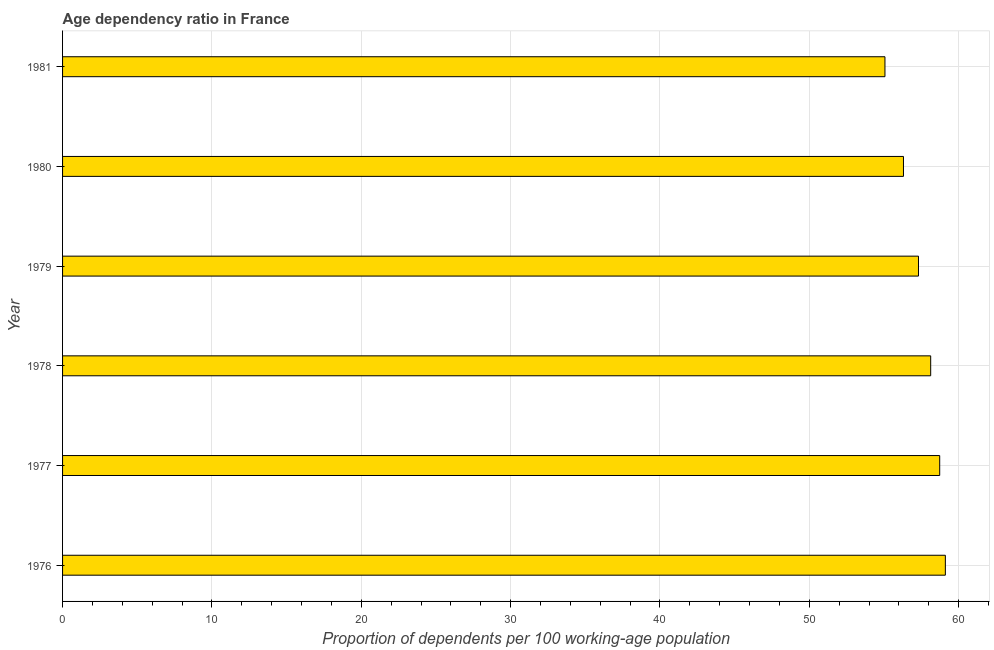Does the graph contain any zero values?
Your answer should be compact. No. Does the graph contain grids?
Make the answer very short. Yes. What is the title of the graph?
Provide a short and direct response. Age dependency ratio in France. What is the label or title of the X-axis?
Keep it short and to the point. Proportion of dependents per 100 working-age population. What is the label or title of the Y-axis?
Your answer should be very brief. Year. What is the age dependency ratio in 1978?
Your answer should be very brief. 58.13. Across all years, what is the maximum age dependency ratio?
Provide a short and direct response. 59.11. Across all years, what is the minimum age dependency ratio?
Your answer should be compact. 55.06. In which year was the age dependency ratio maximum?
Keep it short and to the point. 1976. What is the sum of the age dependency ratio?
Your response must be concise. 344.63. What is the difference between the age dependency ratio in 1976 and 1981?
Make the answer very short. 4.04. What is the average age dependency ratio per year?
Your answer should be compact. 57.44. What is the median age dependency ratio?
Make the answer very short. 57.72. In how many years, is the age dependency ratio greater than 20 ?
Your answer should be compact. 6. Do a majority of the years between 1978 and 1981 (inclusive) have age dependency ratio greater than 14 ?
Keep it short and to the point. Yes. What is the ratio of the age dependency ratio in 1980 to that in 1981?
Your response must be concise. 1.02. Is the age dependency ratio in 1978 less than that in 1980?
Give a very brief answer. No. What is the difference between the highest and the second highest age dependency ratio?
Provide a short and direct response. 0.38. Is the sum of the age dependency ratio in 1978 and 1979 greater than the maximum age dependency ratio across all years?
Offer a very short reply. Yes. What is the difference between the highest and the lowest age dependency ratio?
Provide a short and direct response. 4.04. In how many years, is the age dependency ratio greater than the average age dependency ratio taken over all years?
Your answer should be compact. 3. How many years are there in the graph?
Your response must be concise. 6. What is the difference between two consecutive major ticks on the X-axis?
Make the answer very short. 10. What is the Proportion of dependents per 100 working-age population in 1976?
Provide a succinct answer. 59.11. What is the Proportion of dependents per 100 working-age population of 1977?
Make the answer very short. 58.73. What is the Proportion of dependents per 100 working-age population of 1978?
Your answer should be compact. 58.13. What is the Proportion of dependents per 100 working-age population of 1979?
Your response must be concise. 57.31. What is the Proportion of dependents per 100 working-age population in 1980?
Offer a very short reply. 56.3. What is the Proportion of dependents per 100 working-age population of 1981?
Ensure brevity in your answer.  55.06. What is the difference between the Proportion of dependents per 100 working-age population in 1976 and 1977?
Make the answer very short. 0.38. What is the difference between the Proportion of dependents per 100 working-age population in 1976 and 1978?
Keep it short and to the point. 0.98. What is the difference between the Proportion of dependents per 100 working-age population in 1976 and 1979?
Give a very brief answer. 1.8. What is the difference between the Proportion of dependents per 100 working-age population in 1976 and 1980?
Your answer should be compact. 2.8. What is the difference between the Proportion of dependents per 100 working-age population in 1976 and 1981?
Keep it short and to the point. 4.04. What is the difference between the Proportion of dependents per 100 working-age population in 1977 and 1978?
Your answer should be compact. 0.6. What is the difference between the Proportion of dependents per 100 working-age population in 1977 and 1979?
Give a very brief answer. 1.42. What is the difference between the Proportion of dependents per 100 working-age population in 1977 and 1980?
Make the answer very short. 2.43. What is the difference between the Proportion of dependents per 100 working-age population in 1977 and 1981?
Offer a very short reply. 3.67. What is the difference between the Proportion of dependents per 100 working-age population in 1978 and 1979?
Offer a terse response. 0.82. What is the difference between the Proportion of dependents per 100 working-age population in 1978 and 1980?
Keep it short and to the point. 1.82. What is the difference between the Proportion of dependents per 100 working-age population in 1978 and 1981?
Your answer should be compact. 3.06. What is the difference between the Proportion of dependents per 100 working-age population in 1979 and 1980?
Give a very brief answer. 1.01. What is the difference between the Proportion of dependents per 100 working-age population in 1979 and 1981?
Your answer should be very brief. 2.25. What is the difference between the Proportion of dependents per 100 working-age population in 1980 and 1981?
Your answer should be compact. 1.24. What is the ratio of the Proportion of dependents per 100 working-age population in 1976 to that in 1977?
Offer a terse response. 1.01. What is the ratio of the Proportion of dependents per 100 working-age population in 1976 to that in 1979?
Offer a very short reply. 1.03. What is the ratio of the Proportion of dependents per 100 working-age population in 1976 to that in 1980?
Your response must be concise. 1.05. What is the ratio of the Proportion of dependents per 100 working-age population in 1976 to that in 1981?
Keep it short and to the point. 1.07. What is the ratio of the Proportion of dependents per 100 working-age population in 1977 to that in 1980?
Offer a very short reply. 1.04. What is the ratio of the Proportion of dependents per 100 working-age population in 1977 to that in 1981?
Make the answer very short. 1.07. What is the ratio of the Proportion of dependents per 100 working-age population in 1978 to that in 1979?
Provide a succinct answer. 1.01. What is the ratio of the Proportion of dependents per 100 working-age population in 1978 to that in 1980?
Provide a short and direct response. 1.03. What is the ratio of the Proportion of dependents per 100 working-age population in 1978 to that in 1981?
Offer a terse response. 1.06. What is the ratio of the Proportion of dependents per 100 working-age population in 1979 to that in 1980?
Offer a very short reply. 1.02. What is the ratio of the Proportion of dependents per 100 working-age population in 1979 to that in 1981?
Offer a very short reply. 1.04. 